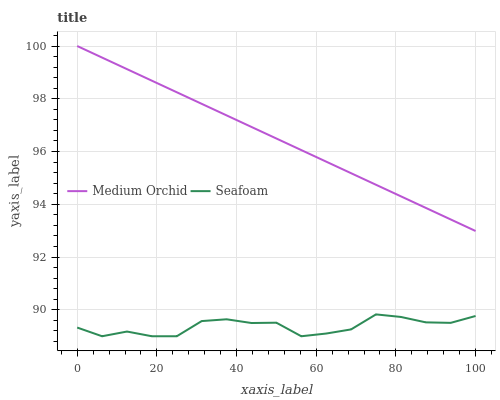Does Seafoam have the minimum area under the curve?
Answer yes or no. Yes. Does Medium Orchid have the maximum area under the curve?
Answer yes or no. Yes. Does Seafoam have the maximum area under the curve?
Answer yes or no. No. Is Medium Orchid the smoothest?
Answer yes or no. Yes. Is Seafoam the roughest?
Answer yes or no. Yes. Is Seafoam the smoothest?
Answer yes or no. No. Does Seafoam have the highest value?
Answer yes or no. No. Is Seafoam less than Medium Orchid?
Answer yes or no. Yes. Is Medium Orchid greater than Seafoam?
Answer yes or no. Yes. Does Seafoam intersect Medium Orchid?
Answer yes or no. No. 